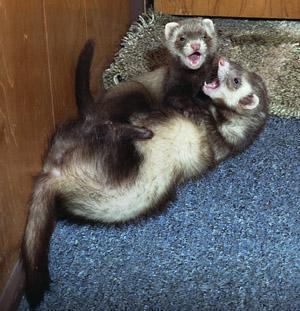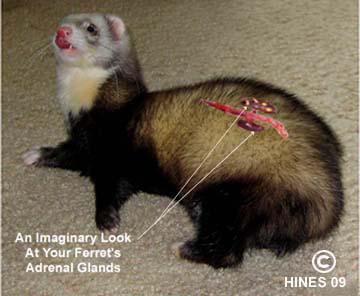The first image is the image on the left, the second image is the image on the right. Assess this claim about the two images: "The left image contains two ferrets.". Correct or not? Answer yes or no. Yes. The first image is the image on the left, the second image is the image on the right. Evaluate the accuracy of this statement regarding the images: "The left image contains two ferrets with their faces close together and their mouths open to some degree.". Is it true? Answer yes or no. Yes. 